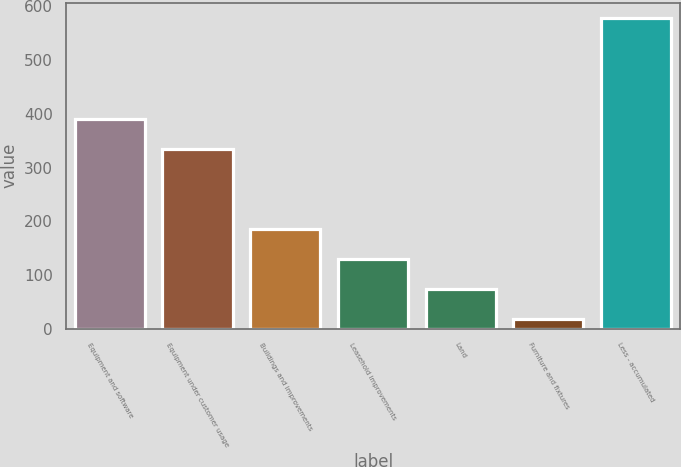Convert chart to OTSL. <chart><loc_0><loc_0><loc_500><loc_500><bar_chart><fcel>Equipment and software<fcel>Equipment under customer usage<fcel>Buildings and improvements<fcel>Leasehold improvements<fcel>Land<fcel>Furniture and fixtures<fcel>Less - accumulated<nl><fcel>390.59<fcel>334.6<fcel>186.37<fcel>130.38<fcel>74.39<fcel>18.4<fcel>578.3<nl></chart> 